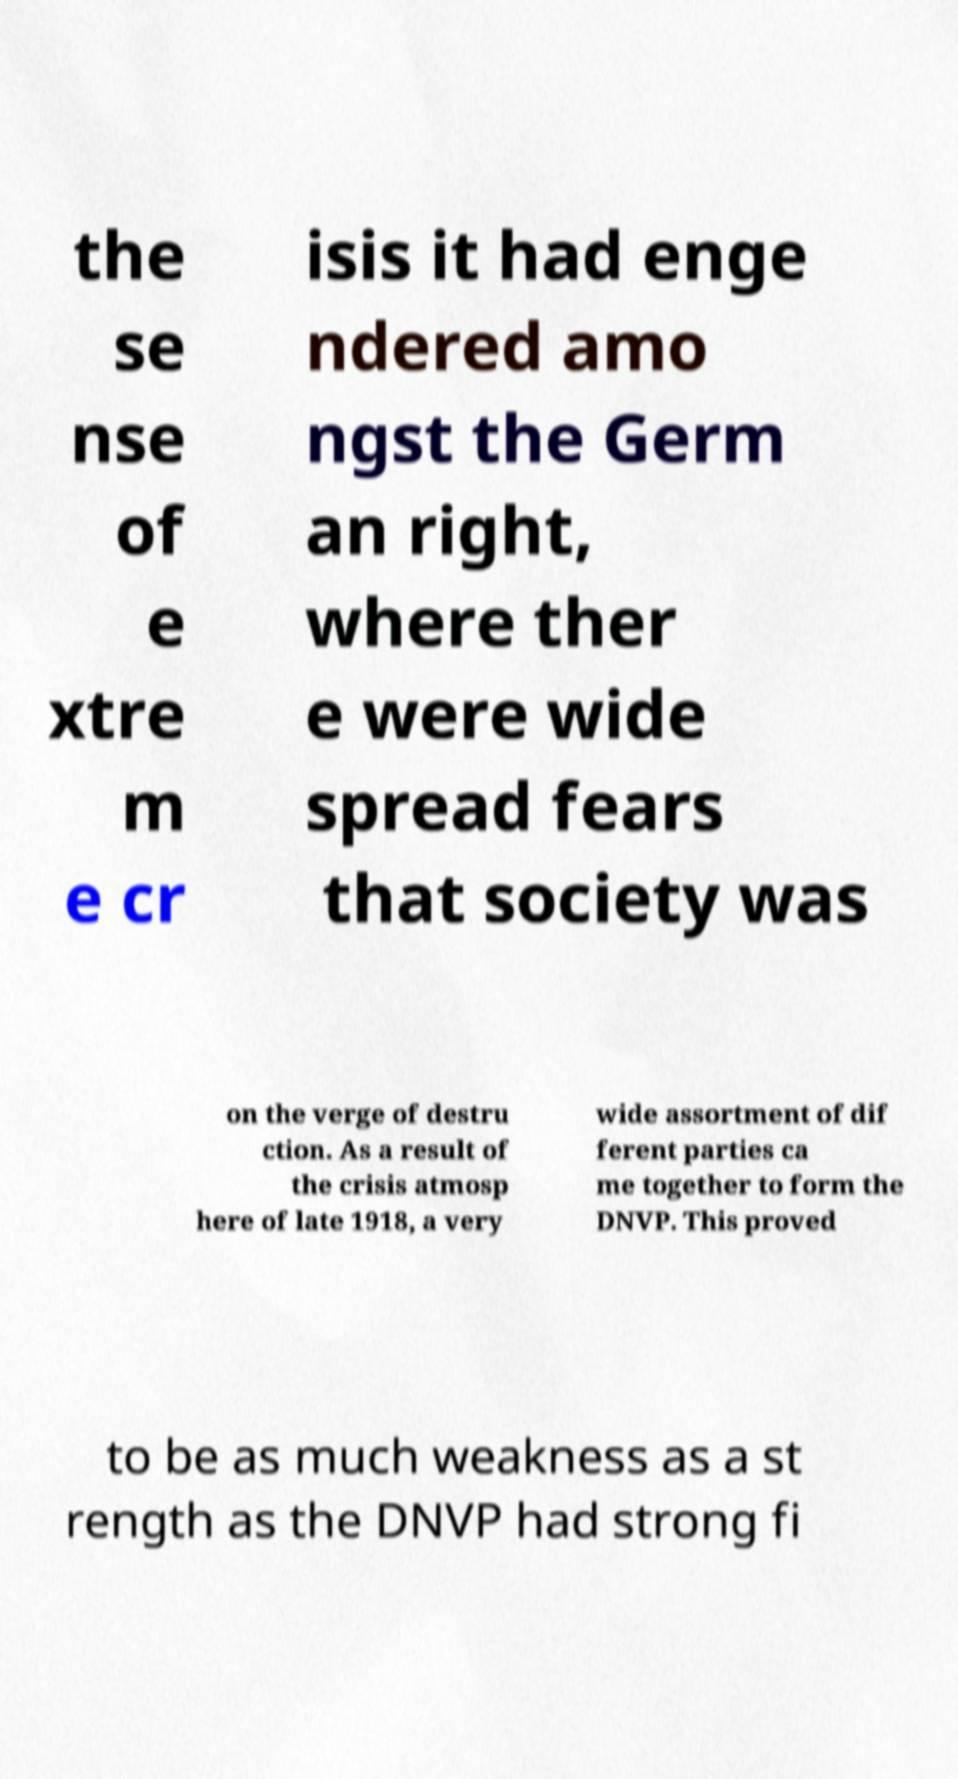Could you assist in decoding the text presented in this image and type it out clearly? the se nse of e xtre m e cr isis it had enge ndered amo ngst the Germ an right, where ther e were wide spread fears that society was on the verge of destru ction. As a result of the crisis atmosp here of late 1918, a very wide assortment of dif ferent parties ca me together to form the DNVP. This proved to be as much weakness as a st rength as the DNVP had strong fi 